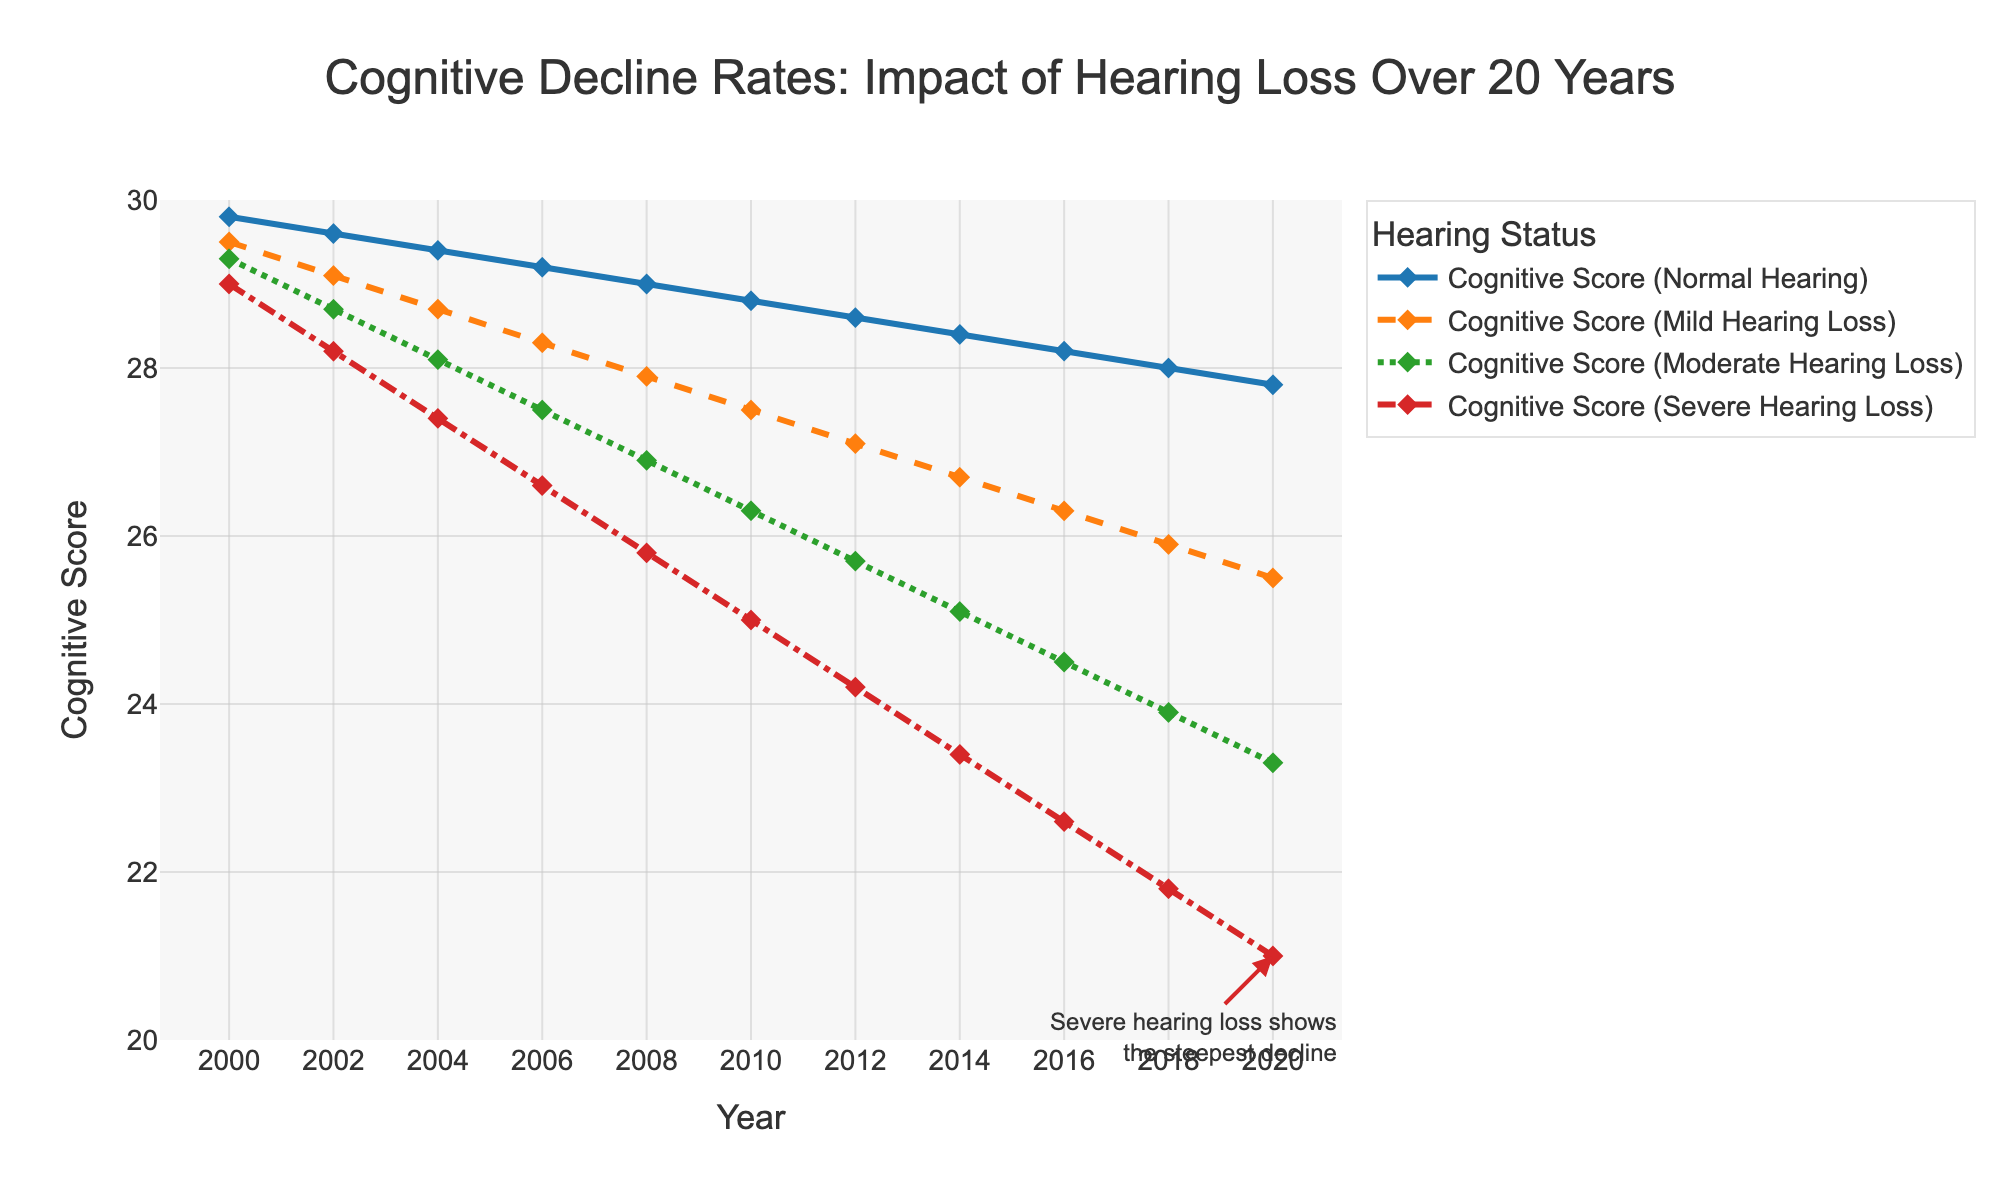What is the cognitive score for individuals with normal hearing in the year 2008? Look at the line representing individuals with normal hearing and find the data point corresponding to the year 2008.
Answer: 29.0 How much did the cognitive score decrease for individuals with severe hearing loss from 2000 to 2020? Subtract the cognitive score in the year 2020 from the score in the year 2000 for individuals with severe hearing loss (29.0 - 21.0).
Answer: 8.0 Compare the cognitive scores of individuals with mild and moderate hearing loss in the year 2016. Which group has a higher score? Look at the data points for the year 2016 on the lines representing mild and moderate hearing loss. Compare the scores (26.3 for mild vs. 24.5 for moderate).
Answer: Mild hearing loss Which group shows the most significant decline in cognitive score over the 20-year period? Compare the overall slopes of the lines for each hearing status. The line with the steepest decline indicates the most significant drop in cognitive scores.
Answer: Severe hearing loss By how much did the cognitive score decrease for individuals with moderate hearing loss between 2004 and 2014? Subtract the cognitive score in 2014 from the score in 2004 for individuals with moderate hearing loss (28.1 - 25.1).
Answer: 3.0 On average, how much did the cognitive score decrease per year for the group with severe hearing loss? Calculate the total decline over 20 years (29.0 - 21.0 = 8.0) and divide by the number of years (20), resulting in an average annual decline (8.0 / 20).
Answer: 0.4 What is the visual indicator used for individuals with moderate hearing loss? Observe the plot and identify the line style and marker used for the moderate hearing loss group.
Answer: Green line with dotdashed style and diamond markers 